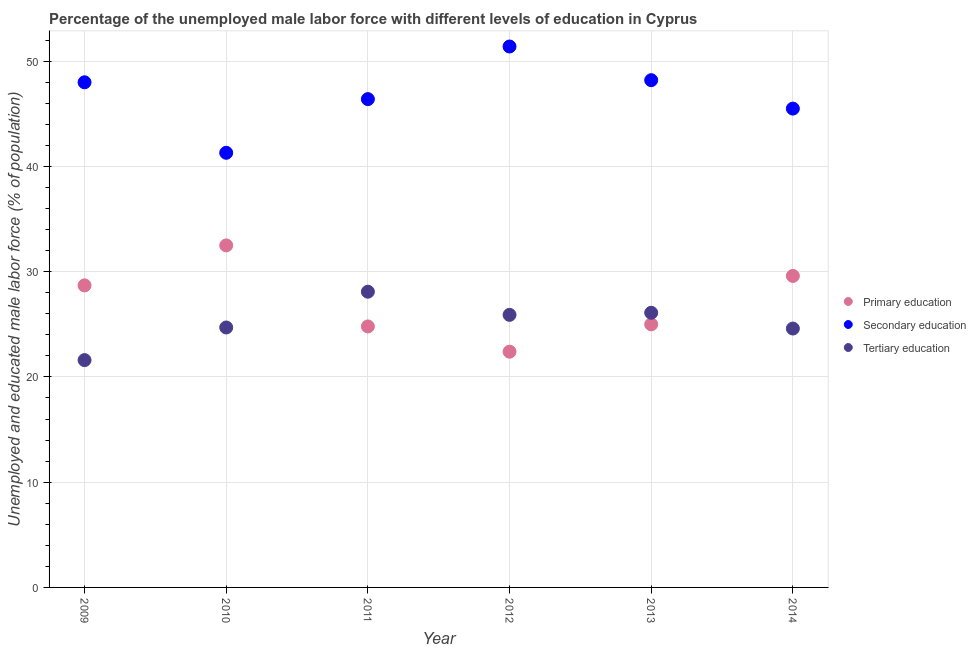What is the percentage of male labor force who received tertiary education in 2012?
Your response must be concise. 25.9. Across all years, what is the maximum percentage of male labor force who received primary education?
Offer a terse response. 32.5. Across all years, what is the minimum percentage of male labor force who received primary education?
Ensure brevity in your answer.  22.4. In which year was the percentage of male labor force who received secondary education maximum?
Provide a short and direct response. 2012. What is the total percentage of male labor force who received secondary education in the graph?
Provide a short and direct response. 280.8. What is the difference between the percentage of male labor force who received secondary education in 2011 and the percentage of male labor force who received primary education in 2014?
Offer a terse response. 16.8. What is the average percentage of male labor force who received tertiary education per year?
Your response must be concise. 25.17. In the year 2009, what is the difference between the percentage of male labor force who received secondary education and percentage of male labor force who received tertiary education?
Your answer should be compact. 26.4. In how many years, is the percentage of male labor force who received secondary education greater than 44 %?
Keep it short and to the point. 5. What is the ratio of the percentage of male labor force who received primary education in 2013 to that in 2014?
Your response must be concise. 0.84. Is the percentage of male labor force who received tertiary education in 2010 less than that in 2013?
Keep it short and to the point. Yes. What is the difference between the highest and the second highest percentage of male labor force who received secondary education?
Keep it short and to the point. 3.2. What is the difference between the highest and the lowest percentage of male labor force who received tertiary education?
Offer a terse response. 6.5. In how many years, is the percentage of male labor force who received secondary education greater than the average percentage of male labor force who received secondary education taken over all years?
Your answer should be very brief. 3. Is the sum of the percentage of male labor force who received primary education in 2012 and 2013 greater than the maximum percentage of male labor force who received tertiary education across all years?
Your answer should be compact. Yes. Is it the case that in every year, the sum of the percentage of male labor force who received primary education and percentage of male labor force who received secondary education is greater than the percentage of male labor force who received tertiary education?
Keep it short and to the point. Yes. Is the percentage of male labor force who received primary education strictly less than the percentage of male labor force who received tertiary education over the years?
Your answer should be very brief. No. How many dotlines are there?
Provide a short and direct response. 3. Does the graph contain any zero values?
Keep it short and to the point. No. Where does the legend appear in the graph?
Ensure brevity in your answer.  Center right. How are the legend labels stacked?
Your answer should be very brief. Vertical. What is the title of the graph?
Make the answer very short. Percentage of the unemployed male labor force with different levels of education in Cyprus. What is the label or title of the X-axis?
Your answer should be compact. Year. What is the label or title of the Y-axis?
Your answer should be compact. Unemployed and educated male labor force (% of population). What is the Unemployed and educated male labor force (% of population) of Primary education in 2009?
Offer a terse response. 28.7. What is the Unemployed and educated male labor force (% of population) in Secondary education in 2009?
Your response must be concise. 48. What is the Unemployed and educated male labor force (% of population) of Tertiary education in 2009?
Offer a terse response. 21.6. What is the Unemployed and educated male labor force (% of population) in Primary education in 2010?
Ensure brevity in your answer.  32.5. What is the Unemployed and educated male labor force (% of population) in Secondary education in 2010?
Ensure brevity in your answer.  41.3. What is the Unemployed and educated male labor force (% of population) in Tertiary education in 2010?
Your response must be concise. 24.7. What is the Unemployed and educated male labor force (% of population) in Primary education in 2011?
Make the answer very short. 24.8. What is the Unemployed and educated male labor force (% of population) in Secondary education in 2011?
Your answer should be compact. 46.4. What is the Unemployed and educated male labor force (% of population) in Tertiary education in 2011?
Your answer should be compact. 28.1. What is the Unemployed and educated male labor force (% of population) in Primary education in 2012?
Keep it short and to the point. 22.4. What is the Unemployed and educated male labor force (% of population) of Secondary education in 2012?
Offer a terse response. 51.4. What is the Unemployed and educated male labor force (% of population) of Tertiary education in 2012?
Keep it short and to the point. 25.9. What is the Unemployed and educated male labor force (% of population) in Primary education in 2013?
Your answer should be compact. 25. What is the Unemployed and educated male labor force (% of population) in Secondary education in 2013?
Your response must be concise. 48.2. What is the Unemployed and educated male labor force (% of population) of Tertiary education in 2013?
Your answer should be compact. 26.1. What is the Unemployed and educated male labor force (% of population) in Primary education in 2014?
Offer a terse response. 29.6. What is the Unemployed and educated male labor force (% of population) in Secondary education in 2014?
Provide a short and direct response. 45.5. What is the Unemployed and educated male labor force (% of population) of Tertiary education in 2014?
Provide a succinct answer. 24.6. Across all years, what is the maximum Unemployed and educated male labor force (% of population) of Primary education?
Offer a very short reply. 32.5. Across all years, what is the maximum Unemployed and educated male labor force (% of population) of Secondary education?
Keep it short and to the point. 51.4. Across all years, what is the maximum Unemployed and educated male labor force (% of population) of Tertiary education?
Keep it short and to the point. 28.1. Across all years, what is the minimum Unemployed and educated male labor force (% of population) in Primary education?
Your answer should be very brief. 22.4. Across all years, what is the minimum Unemployed and educated male labor force (% of population) in Secondary education?
Your answer should be compact. 41.3. Across all years, what is the minimum Unemployed and educated male labor force (% of population) of Tertiary education?
Give a very brief answer. 21.6. What is the total Unemployed and educated male labor force (% of population) of Primary education in the graph?
Make the answer very short. 163. What is the total Unemployed and educated male labor force (% of population) of Secondary education in the graph?
Offer a terse response. 280.8. What is the total Unemployed and educated male labor force (% of population) in Tertiary education in the graph?
Your answer should be compact. 151. What is the difference between the Unemployed and educated male labor force (% of population) in Primary education in 2009 and that in 2011?
Offer a terse response. 3.9. What is the difference between the Unemployed and educated male labor force (% of population) in Tertiary education in 2009 and that in 2011?
Your response must be concise. -6.5. What is the difference between the Unemployed and educated male labor force (% of population) in Primary education in 2009 and that in 2012?
Provide a succinct answer. 6.3. What is the difference between the Unemployed and educated male labor force (% of population) in Primary education in 2009 and that in 2013?
Ensure brevity in your answer.  3.7. What is the difference between the Unemployed and educated male labor force (% of population) of Tertiary education in 2009 and that in 2013?
Offer a very short reply. -4.5. What is the difference between the Unemployed and educated male labor force (% of population) of Secondary education in 2009 and that in 2014?
Provide a succinct answer. 2.5. What is the difference between the Unemployed and educated male labor force (% of population) of Tertiary education in 2009 and that in 2014?
Ensure brevity in your answer.  -3. What is the difference between the Unemployed and educated male labor force (% of population) in Secondary education in 2010 and that in 2011?
Make the answer very short. -5.1. What is the difference between the Unemployed and educated male labor force (% of population) in Primary education in 2010 and that in 2012?
Ensure brevity in your answer.  10.1. What is the difference between the Unemployed and educated male labor force (% of population) of Primary education in 2010 and that in 2013?
Provide a short and direct response. 7.5. What is the difference between the Unemployed and educated male labor force (% of population) in Secondary education in 2010 and that in 2013?
Your response must be concise. -6.9. What is the difference between the Unemployed and educated male labor force (% of population) of Tertiary education in 2010 and that in 2013?
Provide a short and direct response. -1.4. What is the difference between the Unemployed and educated male labor force (% of population) of Primary education in 2010 and that in 2014?
Offer a very short reply. 2.9. What is the difference between the Unemployed and educated male labor force (% of population) in Secondary education in 2010 and that in 2014?
Your answer should be very brief. -4.2. What is the difference between the Unemployed and educated male labor force (% of population) in Tertiary education in 2011 and that in 2012?
Offer a terse response. 2.2. What is the difference between the Unemployed and educated male labor force (% of population) in Tertiary education in 2011 and that in 2013?
Keep it short and to the point. 2. What is the difference between the Unemployed and educated male labor force (% of population) of Primary education in 2011 and that in 2014?
Make the answer very short. -4.8. What is the difference between the Unemployed and educated male labor force (% of population) of Primary education in 2012 and that in 2013?
Keep it short and to the point. -2.6. What is the difference between the Unemployed and educated male labor force (% of population) in Primary education in 2012 and that in 2014?
Offer a very short reply. -7.2. What is the difference between the Unemployed and educated male labor force (% of population) in Secondary education in 2012 and that in 2014?
Ensure brevity in your answer.  5.9. What is the difference between the Unemployed and educated male labor force (% of population) of Tertiary education in 2012 and that in 2014?
Your answer should be compact. 1.3. What is the difference between the Unemployed and educated male labor force (% of population) in Primary education in 2013 and that in 2014?
Provide a succinct answer. -4.6. What is the difference between the Unemployed and educated male labor force (% of population) in Secondary education in 2013 and that in 2014?
Your answer should be compact. 2.7. What is the difference between the Unemployed and educated male labor force (% of population) of Tertiary education in 2013 and that in 2014?
Ensure brevity in your answer.  1.5. What is the difference between the Unemployed and educated male labor force (% of population) of Primary education in 2009 and the Unemployed and educated male labor force (% of population) of Tertiary education in 2010?
Keep it short and to the point. 4. What is the difference between the Unemployed and educated male labor force (% of population) in Secondary education in 2009 and the Unemployed and educated male labor force (% of population) in Tertiary education in 2010?
Keep it short and to the point. 23.3. What is the difference between the Unemployed and educated male labor force (% of population) of Primary education in 2009 and the Unemployed and educated male labor force (% of population) of Secondary education in 2011?
Offer a terse response. -17.7. What is the difference between the Unemployed and educated male labor force (% of population) in Primary education in 2009 and the Unemployed and educated male labor force (% of population) in Tertiary education in 2011?
Provide a short and direct response. 0.6. What is the difference between the Unemployed and educated male labor force (% of population) in Primary education in 2009 and the Unemployed and educated male labor force (% of population) in Secondary education in 2012?
Keep it short and to the point. -22.7. What is the difference between the Unemployed and educated male labor force (% of population) of Secondary education in 2009 and the Unemployed and educated male labor force (% of population) of Tertiary education in 2012?
Ensure brevity in your answer.  22.1. What is the difference between the Unemployed and educated male labor force (% of population) of Primary education in 2009 and the Unemployed and educated male labor force (% of population) of Secondary education in 2013?
Your answer should be very brief. -19.5. What is the difference between the Unemployed and educated male labor force (% of population) in Primary education in 2009 and the Unemployed and educated male labor force (% of population) in Tertiary education in 2013?
Ensure brevity in your answer.  2.6. What is the difference between the Unemployed and educated male labor force (% of population) in Secondary education in 2009 and the Unemployed and educated male labor force (% of population) in Tertiary education in 2013?
Ensure brevity in your answer.  21.9. What is the difference between the Unemployed and educated male labor force (% of population) of Primary education in 2009 and the Unemployed and educated male labor force (% of population) of Secondary education in 2014?
Provide a succinct answer. -16.8. What is the difference between the Unemployed and educated male labor force (% of population) of Secondary education in 2009 and the Unemployed and educated male labor force (% of population) of Tertiary education in 2014?
Give a very brief answer. 23.4. What is the difference between the Unemployed and educated male labor force (% of population) in Primary education in 2010 and the Unemployed and educated male labor force (% of population) in Secondary education in 2011?
Provide a succinct answer. -13.9. What is the difference between the Unemployed and educated male labor force (% of population) of Primary education in 2010 and the Unemployed and educated male labor force (% of population) of Tertiary education in 2011?
Ensure brevity in your answer.  4.4. What is the difference between the Unemployed and educated male labor force (% of population) in Primary education in 2010 and the Unemployed and educated male labor force (% of population) in Secondary education in 2012?
Your response must be concise. -18.9. What is the difference between the Unemployed and educated male labor force (% of population) in Secondary education in 2010 and the Unemployed and educated male labor force (% of population) in Tertiary education in 2012?
Offer a very short reply. 15.4. What is the difference between the Unemployed and educated male labor force (% of population) of Primary education in 2010 and the Unemployed and educated male labor force (% of population) of Secondary education in 2013?
Provide a short and direct response. -15.7. What is the difference between the Unemployed and educated male labor force (% of population) in Secondary education in 2010 and the Unemployed and educated male labor force (% of population) in Tertiary education in 2013?
Provide a short and direct response. 15.2. What is the difference between the Unemployed and educated male labor force (% of population) in Primary education in 2010 and the Unemployed and educated male labor force (% of population) in Secondary education in 2014?
Your answer should be compact. -13. What is the difference between the Unemployed and educated male labor force (% of population) in Secondary education in 2010 and the Unemployed and educated male labor force (% of population) in Tertiary education in 2014?
Give a very brief answer. 16.7. What is the difference between the Unemployed and educated male labor force (% of population) in Primary education in 2011 and the Unemployed and educated male labor force (% of population) in Secondary education in 2012?
Offer a very short reply. -26.6. What is the difference between the Unemployed and educated male labor force (% of population) in Primary education in 2011 and the Unemployed and educated male labor force (% of population) in Secondary education in 2013?
Offer a very short reply. -23.4. What is the difference between the Unemployed and educated male labor force (% of population) in Primary education in 2011 and the Unemployed and educated male labor force (% of population) in Tertiary education in 2013?
Your response must be concise. -1.3. What is the difference between the Unemployed and educated male labor force (% of population) in Secondary education in 2011 and the Unemployed and educated male labor force (% of population) in Tertiary education in 2013?
Make the answer very short. 20.3. What is the difference between the Unemployed and educated male labor force (% of population) in Primary education in 2011 and the Unemployed and educated male labor force (% of population) in Secondary education in 2014?
Make the answer very short. -20.7. What is the difference between the Unemployed and educated male labor force (% of population) in Primary education in 2011 and the Unemployed and educated male labor force (% of population) in Tertiary education in 2014?
Provide a short and direct response. 0.2. What is the difference between the Unemployed and educated male labor force (% of population) in Secondary education in 2011 and the Unemployed and educated male labor force (% of population) in Tertiary education in 2014?
Offer a terse response. 21.8. What is the difference between the Unemployed and educated male labor force (% of population) in Primary education in 2012 and the Unemployed and educated male labor force (% of population) in Secondary education in 2013?
Offer a very short reply. -25.8. What is the difference between the Unemployed and educated male labor force (% of population) in Secondary education in 2012 and the Unemployed and educated male labor force (% of population) in Tertiary education in 2013?
Give a very brief answer. 25.3. What is the difference between the Unemployed and educated male labor force (% of population) in Primary education in 2012 and the Unemployed and educated male labor force (% of population) in Secondary education in 2014?
Make the answer very short. -23.1. What is the difference between the Unemployed and educated male labor force (% of population) of Primary education in 2012 and the Unemployed and educated male labor force (% of population) of Tertiary education in 2014?
Make the answer very short. -2.2. What is the difference between the Unemployed and educated male labor force (% of population) of Secondary education in 2012 and the Unemployed and educated male labor force (% of population) of Tertiary education in 2014?
Provide a short and direct response. 26.8. What is the difference between the Unemployed and educated male labor force (% of population) in Primary education in 2013 and the Unemployed and educated male labor force (% of population) in Secondary education in 2014?
Ensure brevity in your answer.  -20.5. What is the difference between the Unemployed and educated male labor force (% of population) in Secondary education in 2013 and the Unemployed and educated male labor force (% of population) in Tertiary education in 2014?
Make the answer very short. 23.6. What is the average Unemployed and educated male labor force (% of population) in Primary education per year?
Your response must be concise. 27.17. What is the average Unemployed and educated male labor force (% of population) in Secondary education per year?
Make the answer very short. 46.8. What is the average Unemployed and educated male labor force (% of population) of Tertiary education per year?
Keep it short and to the point. 25.17. In the year 2009, what is the difference between the Unemployed and educated male labor force (% of population) of Primary education and Unemployed and educated male labor force (% of population) of Secondary education?
Provide a succinct answer. -19.3. In the year 2009, what is the difference between the Unemployed and educated male labor force (% of population) in Primary education and Unemployed and educated male labor force (% of population) in Tertiary education?
Provide a short and direct response. 7.1. In the year 2009, what is the difference between the Unemployed and educated male labor force (% of population) of Secondary education and Unemployed and educated male labor force (% of population) of Tertiary education?
Offer a terse response. 26.4. In the year 2011, what is the difference between the Unemployed and educated male labor force (% of population) in Primary education and Unemployed and educated male labor force (% of population) in Secondary education?
Offer a very short reply. -21.6. In the year 2011, what is the difference between the Unemployed and educated male labor force (% of population) of Primary education and Unemployed and educated male labor force (% of population) of Tertiary education?
Your answer should be very brief. -3.3. In the year 2011, what is the difference between the Unemployed and educated male labor force (% of population) of Secondary education and Unemployed and educated male labor force (% of population) of Tertiary education?
Provide a succinct answer. 18.3. In the year 2012, what is the difference between the Unemployed and educated male labor force (% of population) in Primary education and Unemployed and educated male labor force (% of population) in Tertiary education?
Your answer should be very brief. -3.5. In the year 2012, what is the difference between the Unemployed and educated male labor force (% of population) of Secondary education and Unemployed and educated male labor force (% of population) of Tertiary education?
Provide a short and direct response. 25.5. In the year 2013, what is the difference between the Unemployed and educated male labor force (% of population) of Primary education and Unemployed and educated male labor force (% of population) of Secondary education?
Offer a terse response. -23.2. In the year 2013, what is the difference between the Unemployed and educated male labor force (% of population) in Primary education and Unemployed and educated male labor force (% of population) in Tertiary education?
Your response must be concise. -1.1. In the year 2013, what is the difference between the Unemployed and educated male labor force (% of population) of Secondary education and Unemployed and educated male labor force (% of population) of Tertiary education?
Your answer should be very brief. 22.1. In the year 2014, what is the difference between the Unemployed and educated male labor force (% of population) in Primary education and Unemployed and educated male labor force (% of population) in Secondary education?
Offer a very short reply. -15.9. In the year 2014, what is the difference between the Unemployed and educated male labor force (% of population) in Primary education and Unemployed and educated male labor force (% of population) in Tertiary education?
Your answer should be very brief. 5. In the year 2014, what is the difference between the Unemployed and educated male labor force (% of population) of Secondary education and Unemployed and educated male labor force (% of population) of Tertiary education?
Provide a succinct answer. 20.9. What is the ratio of the Unemployed and educated male labor force (% of population) in Primary education in 2009 to that in 2010?
Your answer should be compact. 0.88. What is the ratio of the Unemployed and educated male labor force (% of population) of Secondary education in 2009 to that in 2010?
Your response must be concise. 1.16. What is the ratio of the Unemployed and educated male labor force (% of population) of Tertiary education in 2009 to that in 2010?
Ensure brevity in your answer.  0.87. What is the ratio of the Unemployed and educated male labor force (% of population) in Primary education in 2009 to that in 2011?
Keep it short and to the point. 1.16. What is the ratio of the Unemployed and educated male labor force (% of population) in Secondary education in 2009 to that in 2011?
Make the answer very short. 1.03. What is the ratio of the Unemployed and educated male labor force (% of population) of Tertiary education in 2009 to that in 2011?
Ensure brevity in your answer.  0.77. What is the ratio of the Unemployed and educated male labor force (% of population) in Primary education in 2009 to that in 2012?
Offer a terse response. 1.28. What is the ratio of the Unemployed and educated male labor force (% of population) of Secondary education in 2009 to that in 2012?
Ensure brevity in your answer.  0.93. What is the ratio of the Unemployed and educated male labor force (% of population) in Tertiary education in 2009 to that in 2012?
Give a very brief answer. 0.83. What is the ratio of the Unemployed and educated male labor force (% of population) of Primary education in 2009 to that in 2013?
Your answer should be compact. 1.15. What is the ratio of the Unemployed and educated male labor force (% of population) of Secondary education in 2009 to that in 2013?
Your response must be concise. 1. What is the ratio of the Unemployed and educated male labor force (% of population) of Tertiary education in 2009 to that in 2013?
Keep it short and to the point. 0.83. What is the ratio of the Unemployed and educated male labor force (% of population) in Primary education in 2009 to that in 2014?
Make the answer very short. 0.97. What is the ratio of the Unemployed and educated male labor force (% of population) in Secondary education in 2009 to that in 2014?
Give a very brief answer. 1.05. What is the ratio of the Unemployed and educated male labor force (% of population) in Tertiary education in 2009 to that in 2014?
Offer a very short reply. 0.88. What is the ratio of the Unemployed and educated male labor force (% of population) in Primary education in 2010 to that in 2011?
Offer a very short reply. 1.31. What is the ratio of the Unemployed and educated male labor force (% of population) of Secondary education in 2010 to that in 2011?
Ensure brevity in your answer.  0.89. What is the ratio of the Unemployed and educated male labor force (% of population) of Tertiary education in 2010 to that in 2011?
Your response must be concise. 0.88. What is the ratio of the Unemployed and educated male labor force (% of population) in Primary education in 2010 to that in 2012?
Offer a very short reply. 1.45. What is the ratio of the Unemployed and educated male labor force (% of population) of Secondary education in 2010 to that in 2012?
Ensure brevity in your answer.  0.8. What is the ratio of the Unemployed and educated male labor force (% of population) in Tertiary education in 2010 to that in 2012?
Your response must be concise. 0.95. What is the ratio of the Unemployed and educated male labor force (% of population) of Secondary education in 2010 to that in 2013?
Provide a short and direct response. 0.86. What is the ratio of the Unemployed and educated male labor force (% of population) of Tertiary education in 2010 to that in 2013?
Your answer should be very brief. 0.95. What is the ratio of the Unemployed and educated male labor force (% of population) in Primary education in 2010 to that in 2014?
Offer a terse response. 1.1. What is the ratio of the Unemployed and educated male labor force (% of population) in Secondary education in 2010 to that in 2014?
Offer a terse response. 0.91. What is the ratio of the Unemployed and educated male labor force (% of population) in Tertiary education in 2010 to that in 2014?
Provide a succinct answer. 1. What is the ratio of the Unemployed and educated male labor force (% of population) of Primary education in 2011 to that in 2012?
Keep it short and to the point. 1.11. What is the ratio of the Unemployed and educated male labor force (% of population) in Secondary education in 2011 to that in 2012?
Your answer should be compact. 0.9. What is the ratio of the Unemployed and educated male labor force (% of population) of Tertiary education in 2011 to that in 2012?
Offer a terse response. 1.08. What is the ratio of the Unemployed and educated male labor force (% of population) in Primary education in 2011 to that in 2013?
Provide a short and direct response. 0.99. What is the ratio of the Unemployed and educated male labor force (% of population) of Secondary education in 2011 to that in 2013?
Make the answer very short. 0.96. What is the ratio of the Unemployed and educated male labor force (% of population) of Tertiary education in 2011 to that in 2013?
Keep it short and to the point. 1.08. What is the ratio of the Unemployed and educated male labor force (% of population) in Primary education in 2011 to that in 2014?
Provide a short and direct response. 0.84. What is the ratio of the Unemployed and educated male labor force (% of population) of Secondary education in 2011 to that in 2014?
Ensure brevity in your answer.  1.02. What is the ratio of the Unemployed and educated male labor force (% of population) in Tertiary education in 2011 to that in 2014?
Offer a terse response. 1.14. What is the ratio of the Unemployed and educated male labor force (% of population) of Primary education in 2012 to that in 2013?
Your response must be concise. 0.9. What is the ratio of the Unemployed and educated male labor force (% of population) of Secondary education in 2012 to that in 2013?
Your response must be concise. 1.07. What is the ratio of the Unemployed and educated male labor force (% of population) of Primary education in 2012 to that in 2014?
Offer a very short reply. 0.76. What is the ratio of the Unemployed and educated male labor force (% of population) of Secondary education in 2012 to that in 2014?
Keep it short and to the point. 1.13. What is the ratio of the Unemployed and educated male labor force (% of population) in Tertiary education in 2012 to that in 2014?
Provide a short and direct response. 1.05. What is the ratio of the Unemployed and educated male labor force (% of population) of Primary education in 2013 to that in 2014?
Offer a very short reply. 0.84. What is the ratio of the Unemployed and educated male labor force (% of population) of Secondary education in 2013 to that in 2014?
Give a very brief answer. 1.06. What is the ratio of the Unemployed and educated male labor force (% of population) of Tertiary education in 2013 to that in 2014?
Offer a very short reply. 1.06. What is the difference between the highest and the second highest Unemployed and educated male labor force (% of population) of Tertiary education?
Provide a short and direct response. 2. What is the difference between the highest and the lowest Unemployed and educated male labor force (% of population) in Primary education?
Your answer should be very brief. 10.1. What is the difference between the highest and the lowest Unemployed and educated male labor force (% of population) of Secondary education?
Your response must be concise. 10.1. 